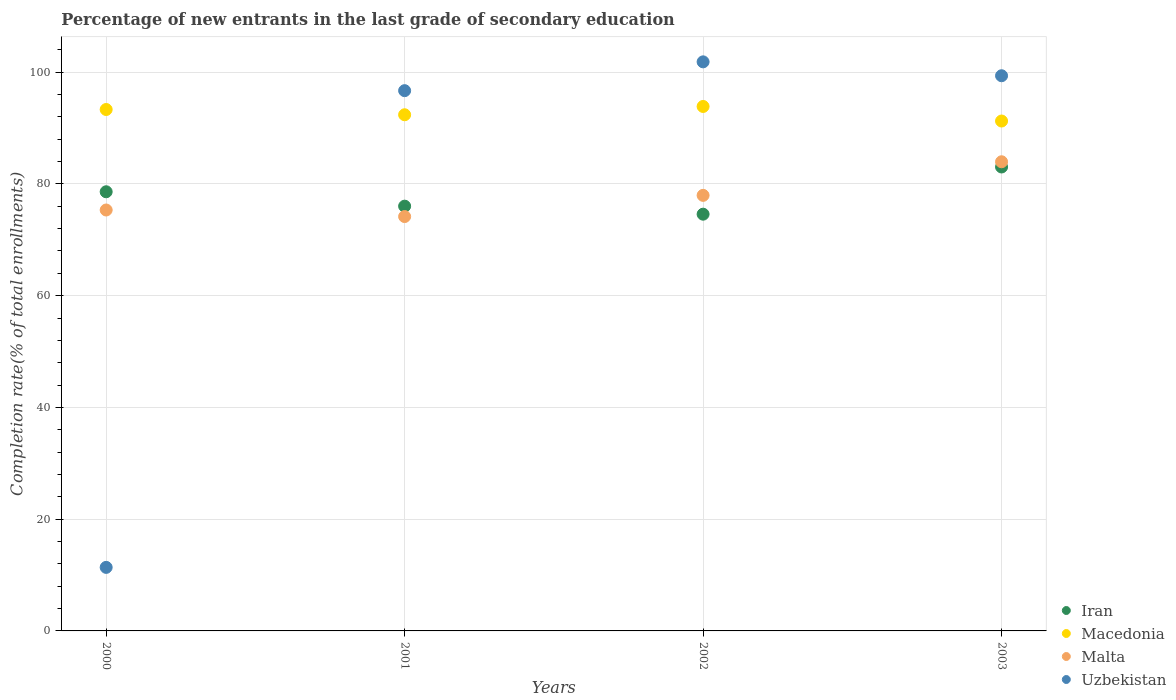How many different coloured dotlines are there?
Provide a succinct answer. 4. What is the percentage of new entrants in Iran in 2000?
Ensure brevity in your answer.  78.59. Across all years, what is the maximum percentage of new entrants in Iran?
Offer a very short reply. 83.03. Across all years, what is the minimum percentage of new entrants in Uzbekistan?
Give a very brief answer. 11.37. In which year was the percentage of new entrants in Malta maximum?
Provide a succinct answer. 2003. What is the total percentage of new entrants in Malta in the graph?
Keep it short and to the point. 311.4. What is the difference between the percentage of new entrants in Malta in 2000 and that in 2001?
Make the answer very short. 1.17. What is the difference between the percentage of new entrants in Uzbekistan in 2000 and the percentage of new entrants in Macedonia in 2001?
Your answer should be very brief. -81. What is the average percentage of new entrants in Macedonia per year?
Provide a short and direct response. 92.7. In the year 2003, what is the difference between the percentage of new entrants in Malta and percentage of new entrants in Macedonia?
Offer a very short reply. -7.29. In how many years, is the percentage of new entrants in Uzbekistan greater than 8 %?
Offer a terse response. 4. What is the ratio of the percentage of new entrants in Macedonia in 2000 to that in 2001?
Give a very brief answer. 1.01. Is the percentage of new entrants in Uzbekistan in 2001 less than that in 2003?
Offer a very short reply. Yes. What is the difference between the highest and the second highest percentage of new entrants in Iran?
Your answer should be compact. 4.44. What is the difference between the highest and the lowest percentage of new entrants in Macedonia?
Offer a very short reply. 2.61. In how many years, is the percentage of new entrants in Uzbekistan greater than the average percentage of new entrants in Uzbekistan taken over all years?
Your answer should be compact. 3. Is the sum of the percentage of new entrants in Iran in 2001 and 2003 greater than the maximum percentage of new entrants in Malta across all years?
Your answer should be compact. Yes. Is it the case that in every year, the sum of the percentage of new entrants in Uzbekistan and percentage of new entrants in Macedonia  is greater than the sum of percentage of new entrants in Iran and percentage of new entrants in Malta?
Your response must be concise. No. Does the percentage of new entrants in Uzbekistan monotonically increase over the years?
Your answer should be very brief. No. Is the percentage of new entrants in Uzbekistan strictly greater than the percentage of new entrants in Iran over the years?
Your response must be concise. No. How many dotlines are there?
Your answer should be very brief. 4. What is the difference between two consecutive major ticks on the Y-axis?
Your response must be concise. 20. Does the graph contain grids?
Make the answer very short. Yes. Where does the legend appear in the graph?
Give a very brief answer. Bottom right. How many legend labels are there?
Offer a very short reply. 4. How are the legend labels stacked?
Ensure brevity in your answer.  Vertical. What is the title of the graph?
Ensure brevity in your answer.  Percentage of new entrants in the last grade of secondary education. What is the label or title of the X-axis?
Offer a terse response. Years. What is the label or title of the Y-axis?
Offer a terse response. Completion rate(% of total enrollments). What is the Completion rate(% of total enrollments) of Iran in 2000?
Provide a short and direct response. 78.59. What is the Completion rate(% of total enrollments) in Macedonia in 2000?
Your answer should be very brief. 93.31. What is the Completion rate(% of total enrollments) in Malta in 2000?
Provide a short and direct response. 75.33. What is the Completion rate(% of total enrollments) in Uzbekistan in 2000?
Provide a short and direct response. 11.37. What is the Completion rate(% of total enrollments) in Iran in 2001?
Your answer should be compact. 76.02. What is the Completion rate(% of total enrollments) in Macedonia in 2001?
Your response must be concise. 92.37. What is the Completion rate(% of total enrollments) of Malta in 2001?
Make the answer very short. 74.16. What is the Completion rate(% of total enrollments) of Uzbekistan in 2001?
Make the answer very short. 96.69. What is the Completion rate(% of total enrollments) of Iran in 2002?
Keep it short and to the point. 74.58. What is the Completion rate(% of total enrollments) in Macedonia in 2002?
Offer a very short reply. 93.86. What is the Completion rate(% of total enrollments) in Malta in 2002?
Make the answer very short. 77.95. What is the Completion rate(% of total enrollments) in Uzbekistan in 2002?
Offer a very short reply. 101.84. What is the Completion rate(% of total enrollments) of Iran in 2003?
Your answer should be compact. 83.03. What is the Completion rate(% of total enrollments) in Macedonia in 2003?
Keep it short and to the point. 91.25. What is the Completion rate(% of total enrollments) of Malta in 2003?
Give a very brief answer. 83.96. What is the Completion rate(% of total enrollments) in Uzbekistan in 2003?
Provide a short and direct response. 99.36. Across all years, what is the maximum Completion rate(% of total enrollments) of Iran?
Make the answer very short. 83.03. Across all years, what is the maximum Completion rate(% of total enrollments) of Macedonia?
Your answer should be compact. 93.86. Across all years, what is the maximum Completion rate(% of total enrollments) of Malta?
Provide a short and direct response. 83.96. Across all years, what is the maximum Completion rate(% of total enrollments) in Uzbekistan?
Your response must be concise. 101.84. Across all years, what is the minimum Completion rate(% of total enrollments) in Iran?
Make the answer very short. 74.58. Across all years, what is the minimum Completion rate(% of total enrollments) of Macedonia?
Your answer should be compact. 91.25. Across all years, what is the minimum Completion rate(% of total enrollments) in Malta?
Provide a succinct answer. 74.16. Across all years, what is the minimum Completion rate(% of total enrollments) of Uzbekistan?
Your response must be concise. 11.37. What is the total Completion rate(% of total enrollments) of Iran in the graph?
Your response must be concise. 312.22. What is the total Completion rate(% of total enrollments) in Macedonia in the graph?
Give a very brief answer. 370.8. What is the total Completion rate(% of total enrollments) in Malta in the graph?
Give a very brief answer. 311.4. What is the total Completion rate(% of total enrollments) in Uzbekistan in the graph?
Your answer should be compact. 309.26. What is the difference between the Completion rate(% of total enrollments) in Iran in 2000 and that in 2001?
Make the answer very short. 2.58. What is the difference between the Completion rate(% of total enrollments) in Macedonia in 2000 and that in 2001?
Give a very brief answer. 0.94. What is the difference between the Completion rate(% of total enrollments) of Malta in 2000 and that in 2001?
Your response must be concise. 1.17. What is the difference between the Completion rate(% of total enrollments) in Uzbekistan in 2000 and that in 2001?
Provide a succinct answer. -85.31. What is the difference between the Completion rate(% of total enrollments) of Iran in 2000 and that in 2002?
Give a very brief answer. 4.01. What is the difference between the Completion rate(% of total enrollments) in Macedonia in 2000 and that in 2002?
Your response must be concise. -0.54. What is the difference between the Completion rate(% of total enrollments) of Malta in 2000 and that in 2002?
Your answer should be very brief. -2.62. What is the difference between the Completion rate(% of total enrollments) of Uzbekistan in 2000 and that in 2002?
Keep it short and to the point. -90.47. What is the difference between the Completion rate(% of total enrollments) in Iran in 2000 and that in 2003?
Make the answer very short. -4.44. What is the difference between the Completion rate(% of total enrollments) in Macedonia in 2000 and that in 2003?
Your response must be concise. 2.06. What is the difference between the Completion rate(% of total enrollments) of Malta in 2000 and that in 2003?
Provide a short and direct response. -8.63. What is the difference between the Completion rate(% of total enrollments) in Uzbekistan in 2000 and that in 2003?
Make the answer very short. -87.98. What is the difference between the Completion rate(% of total enrollments) of Iran in 2001 and that in 2002?
Give a very brief answer. 1.43. What is the difference between the Completion rate(% of total enrollments) in Macedonia in 2001 and that in 2002?
Offer a very short reply. -1.49. What is the difference between the Completion rate(% of total enrollments) in Malta in 2001 and that in 2002?
Give a very brief answer. -3.79. What is the difference between the Completion rate(% of total enrollments) in Uzbekistan in 2001 and that in 2002?
Make the answer very short. -5.16. What is the difference between the Completion rate(% of total enrollments) of Iran in 2001 and that in 2003?
Your answer should be very brief. -7.01. What is the difference between the Completion rate(% of total enrollments) in Macedonia in 2001 and that in 2003?
Your response must be concise. 1.12. What is the difference between the Completion rate(% of total enrollments) in Malta in 2001 and that in 2003?
Offer a terse response. -9.81. What is the difference between the Completion rate(% of total enrollments) in Uzbekistan in 2001 and that in 2003?
Give a very brief answer. -2.67. What is the difference between the Completion rate(% of total enrollments) of Iran in 2002 and that in 2003?
Your response must be concise. -8.45. What is the difference between the Completion rate(% of total enrollments) in Macedonia in 2002 and that in 2003?
Your answer should be very brief. 2.61. What is the difference between the Completion rate(% of total enrollments) of Malta in 2002 and that in 2003?
Your answer should be compact. -6.01. What is the difference between the Completion rate(% of total enrollments) in Uzbekistan in 2002 and that in 2003?
Offer a terse response. 2.49. What is the difference between the Completion rate(% of total enrollments) of Iran in 2000 and the Completion rate(% of total enrollments) of Macedonia in 2001?
Provide a succinct answer. -13.78. What is the difference between the Completion rate(% of total enrollments) of Iran in 2000 and the Completion rate(% of total enrollments) of Malta in 2001?
Make the answer very short. 4.44. What is the difference between the Completion rate(% of total enrollments) in Iran in 2000 and the Completion rate(% of total enrollments) in Uzbekistan in 2001?
Make the answer very short. -18.09. What is the difference between the Completion rate(% of total enrollments) in Macedonia in 2000 and the Completion rate(% of total enrollments) in Malta in 2001?
Offer a terse response. 19.16. What is the difference between the Completion rate(% of total enrollments) of Macedonia in 2000 and the Completion rate(% of total enrollments) of Uzbekistan in 2001?
Give a very brief answer. -3.37. What is the difference between the Completion rate(% of total enrollments) of Malta in 2000 and the Completion rate(% of total enrollments) of Uzbekistan in 2001?
Make the answer very short. -21.36. What is the difference between the Completion rate(% of total enrollments) in Iran in 2000 and the Completion rate(% of total enrollments) in Macedonia in 2002?
Provide a short and direct response. -15.27. What is the difference between the Completion rate(% of total enrollments) in Iran in 2000 and the Completion rate(% of total enrollments) in Malta in 2002?
Offer a terse response. 0.64. What is the difference between the Completion rate(% of total enrollments) of Iran in 2000 and the Completion rate(% of total enrollments) of Uzbekistan in 2002?
Provide a succinct answer. -23.25. What is the difference between the Completion rate(% of total enrollments) of Macedonia in 2000 and the Completion rate(% of total enrollments) of Malta in 2002?
Ensure brevity in your answer.  15.37. What is the difference between the Completion rate(% of total enrollments) of Macedonia in 2000 and the Completion rate(% of total enrollments) of Uzbekistan in 2002?
Ensure brevity in your answer.  -8.53. What is the difference between the Completion rate(% of total enrollments) of Malta in 2000 and the Completion rate(% of total enrollments) of Uzbekistan in 2002?
Keep it short and to the point. -26.51. What is the difference between the Completion rate(% of total enrollments) in Iran in 2000 and the Completion rate(% of total enrollments) in Macedonia in 2003?
Make the answer very short. -12.66. What is the difference between the Completion rate(% of total enrollments) of Iran in 2000 and the Completion rate(% of total enrollments) of Malta in 2003?
Your response must be concise. -5.37. What is the difference between the Completion rate(% of total enrollments) in Iran in 2000 and the Completion rate(% of total enrollments) in Uzbekistan in 2003?
Your answer should be very brief. -20.76. What is the difference between the Completion rate(% of total enrollments) of Macedonia in 2000 and the Completion rate(% of total enrollments) of Malta in 2003?
Ensure brevity in your answer.  9.35. What is the difference between the Completion rate(% of total enrollments) in Macedonia in 2000 and the Completion rate(% of total enrollments) in Uzbekistan in 2003?
Offer a terse response. -6.04. What is the difference between the Completion rate(% of total enrollments) of Malta in 2000 and the Completion rate(% of total enrollments) of Uzbekistan in 2003?
Offer a very short reply. -24.03. What is the difference between the Completion rate(% of total enrollments) of Iran in 2001 and the Completion rate(% of total enrollments) of Macedonia in 2002?
Your answer should be very brief. -17.84. What is the difference between the Completion rate(% of total enrollments) of Iran in 2001 and the Completion rate(% of total enrollments) of Malta in 2002?
Provide a succinct answer. -1.93. What is the difference between the Completion rate(% of total enrollments) in Iran in 2001 and the Completion rate(% of total enrollments) in Uzbekistan in 2002?
Offer a very short reply. -25.83. What is the difference between the Completion rate(% of total enrollments) in Macedonia in 2001 and the Completion rate(% of total enrollments) in Malta in 2002?
Offer a terse response. 14.43. What is the difference between the Completion rate(% of total enrollments) of Macedonia in 2001 and the Completion rate(% of total enrollments) of Uzbekistan in 2002?
Provide a short and direct response. -9.47. What is the difference between the Completion rate(% of total enrollments) of Malta in 2001 and the Completion rate(% of total enrollments) of Uzbekistan in 2002?
Offer a very short reply. -27.69. What is the difference between the Completion rate(% of total enrollments) of Iran in 2001 and the Completion rate(% of total enrollments) of Macedonia in 2003?
Your answer should be very brief. -15.24. What is the difference between the Completion rate(% of total enrollments) in Iran in 2001 and the Completion rate(% of total enrollments) in Malta in 2003?
Your answer should be very brief. -7.95. What is the difference between the Completion rate(% of total enrollments) in Iran in 2001 and the Completion rate(% of total enrollments) in Uzbekistan in 2003?
Make the answer very short. -23.34. What is the difference between the Completion rate(% of total enrollments) in Macedonia in 2001 and the Completion rate(% of total enrollments) in Malta in 2003?
Keep it short and to the point. 8.41. What is the difference between the Completion rate(% of total enrollments) of Macedonia in 2001 and the Completion rate(% of total enrollments) of Uzbekistan in 2003?
Your answer should be compact. -6.98. What is the difference between the Completion rate(% of total enrollments) of Malta in 2001 and the Completion rate(% of total enrollments) of Uzbekistan in 2003?
Your response must be concise. -25.2. What is the difference between the Completion rate(% of total enrollments) of Iran in 2002 and the Completion rate(% of total enrollments) of Macedonia in 2003?
Your answer should be compact. -16.67. What is the difference between the Completion rate(% of total enrollments) of Iran in 2002 and the Completion rate(% of total enrollments) of Malta in 2003?
Provide a short and direct response. -9.38. What is the difference between the Completion rate(% of total enrollments) in Iran in 2002 and the Completion rate(% of total enrollments) in Uzbekistan in 2003?
Your answer should be very brief. -24.78. What is the difference between the Completion rate(% of total enrollments) of Macedonia in 2002 and the Completion rate(% of total enrollments) of Malta in 2003?
Give a very brief answer. 9.9. What is the difference between the Completion rate(% of total enrollments) of Macedonia in 2002 and the Completion rate(% of total enrollments) of Uzbekistan in 2003?
Provide a succinct answer. -5.5. What is the difference between the Completion rate(% of total enrollments) of Malta in 2002 and the Completion rate(% of total enrollments) of Uzbekistan in 2003?
Make the answer very short. -21.41. What is the average Completion rate(% of total enrollments) in Iran per year?
Your answer should be very brief. 78.05. What is the average Completion rate(% of total enrollments) of Macedonia per year?
Your answer should be compact. 92.7. What is the average Completion rate(% of total enrollments) in Malta per year?
Your response must be concise. 77.85. What is the average Completion rate(% of total enrollments) in Uzbekistan per year?
Your answer should be very brief. 77.31. In the year 2000, what is the difference between the Completion rate(% of total enrollments) in Iran and Completion rate(% of total enrollments) in Macedonia?
Offer a very short reply. -14.72. In the year 2000, what is the difference between the Completion rate(% of total enrollments) in Iran and Completion rate(% of total enrollments) in Malta?
Provide a short and direct response. 3.26. In the year 2000, what is the difference between the Completion rate(% of total enrollments) of Iran and Completion rate(% of total enrollments) of Uzbekistan?
Offer a very short reply. 67.22. In the year 2000, what is the difference between the Completion rate(% of total enrollments) of Macedonia and Completion rate(% of total enrollments) of Malta?
Make the answer very short. 17.99. In the year 2000, what is the difference between the Completion rate(% of total enrollments) of Macedonia and Completion rate(% of total enrollments) of Uzbekistan?
Keep it short and to the point. 81.94. In the year 2000, what is the difference between the Completion rate(% of total enrollments) in Malta and Completion rate(% of total enrollments) in Uzbekistan?
Your answer should be very brief. 63.96. In the year 2001, what is the difference between the Completion rate(% of total enrollments) in Iran and Completion rate(% of total enrollments) in Macedonia?
Your answer should be very brief. -16.36. In the year 2001, what is the difference between the Completion rate(% of total enrollments) in Iran and Completion rate(% of total enrollments) in Malta?
Make the answer very short. 1.86. In the year 2001, what is the difference between the Completion rate(% of total enrollments) in Iran and Completion rate(% of total enrollments) in Uzbekistan?
Keep it short and to the point. -20.67. In the year 2001, what is the difference between the Completion rate(% of total enrollments) in Macedonia and Completion rate(% of total enrollments) in Malta?
Offer a very short reply. 18.22. In the year 2001, what is the difference between the Completion rate(% of total enrollments) of Macedonia and Completion rate(% of total enrollments) of Uzbekistan?
Your answer should be very brief. -4.31. In the year 2001, what is the difference between the Completion rate(% of total enrollments) of Malta and Completion rate(% of total enrollments) of Uzbekistan?
Make the answer very short. -22.53. In the year 2002, what is the difference between the Completion rate(% of total enrollments) of Iran and Completion rate(% of total enrollments) of Macedonia?
Provide a short and direct response. -19.28. In the year 2002, what is the difference between the Completion rate(% of total enrollments) of Iran and Completion rate(% of total enrollments) of Malta?
Offer a very short reply. -3.37. In the year 2002, what is the difference between the Completion rate(% of total enrollments) of Iran and Completion rate(% of total enrollments) of Uzbekistan?
Provide a short and direct response. -27.26. In the year 2002, what is the difference between the Completion rate(% of total enrollments) of Macedonia and Completion rate(% of total enrollments) of Malta?
Make the answer very short. 15.91. In the year 2002, what is the difference between the Completion rate(% of total enrollments) of Macedonia and Completion rate(% of total enrollments) of Uzbekistan?
Offer a terse response. -7.98. In the year 2002, what is the difference between the Completion rate(% of total enrollments) in Malta and Completion rate(% of total enrollments) in Uzbekistan?
Provide a succinct answer. -23.89. In the year 2003, what is the difference between the Completion rate(% of total enrollments) of Iran and Completion rate(% of total enrollments) of Macedonia?
Keep it short and to the point. -8.22. In the year 2003, what is the difference between the Completion rate(% of total enrollments) of Iran and Completion rate(% of total enrollments) of Malta?
Keep it short and to the point. -0.93. In the year 2003, what is the difference between the Completion rate(% of total enrollments) in Iran and Completion rate(% of total enrollments) in Uzbekistan?
Ensure brevity in your answer.  -16.33. In the year 2003, what is the difference between the Completion rate(% of total enrollments) in Macedonia and Completion rate(% of total enrollments) in Malta?
Give a very brief answer. 7.29. In the year 2003, what is the difference between the Completion rate(% of total enrollments) in Macedonia and Completion rate(% of total enrollments) in Uzbekistan?
Provide a short and direct response. -8.1. In the year 2003, what is the difference between the Completion rate(% of total enrollments) in Malta and Completion rate(% of total enrollments) in Uzbekistan?
Ensure brevity in your answer.  -15.39. What is the ratio of the Completion rate(% of total enrollments) in Iran in 2000 to that in 2001?
Give a very brief answer. 1.03. What is the ratio of the Completion rate(% of total enrollments) of Macedonia in 2000 to that in 2001?
Provide a short and direct response. 1.01. What is the ratio of the Completion rate(% of total enrollments) of Malta in 2000 to that in 2001?
Provide a succinct answer. 1.02. What is the ratio of the Completion rate(% of total enrollments) in Uzbekistan in 2000 to that in 2001?
Your answer should be compact. 0.12. What is the ratio of the Completion rate(% of total enrollments) of Iran in 2000 to that in 2002?
Offer a terse response. 1.05. What is the ratio of the Completion rate(% of total enrollments) in Malta in 2000 to that in 2002?
Ensure brevity in your answer.  0.97. What is the ratio of the Completion rate(% of total enrollments) of Uzbekistan in 2000 to that in 2002?
Keep it short and to the point. 0.11. What is the ratio of the Completion rate(% of total enrollments) of Iran in 2000 to that in 2003?
Offer a terse response. 0.95. What is the ratio of the Completion rate(% of total enrollments) of Macedonia in 2000 to that in 2003?
Make the answer very short. 1.02. What is the ratio of the Completion rate(% of total enrollments) of Malta in 2000 to that in 2003?
Make the answer very short. 0.9. What is the ratio of the Completion rate(% of total enrollments) in Uzbekistan in 2000 to that in 2003?
Your response must be concise. 0.11. What is the ratio of the Completion rate(% of total enrollments) of Iran in 2001 to that in 2002?
Your answer should be very brief. 1.02. What is the ratio of the Completion rate(% of total enrollments) in Macedonia in 2001 to that in 2002?
Provide a succinct answer. 0.98. What is the ratio of the Completion rate(% of total enrollments) in Malta in 2001 to that in 2002?
Your answer should be compact. 0.95. What is the ratio of the Completion rate(% of total enrollments) of Uzbekistan in 2001 to that in 2002?
Offer a very short reply. 0.95. What is the ratio of the Completion rate(% of total enrollments) of Iran in 2001 to that in 2003?
Your answer should be compact. 0.92. What is the ratio of the Completion rate(% of total enrollments) of Macedonia in 2001 to that in 2003?
Your response must be concise. 1.01. What is the ratio of the Completion rate(% of total enrollments) in Malta in 2001 to that in 2003?
Your response must be concise. 0.88. What is the ratio of the Completion rate(% of total enrollments) in Uzbekistan in 2001 to that in 2003?
Ensure brevity in your answer.  0.97. What is the ratio of the Completion rate(% of total enrollments) in Iran in 2002 to that in 2003?
Your response must be concise. 0.9. What is the ratio of the Completion rate(% of total enrollments) in Macedonia in 2002 to that in 2003?
Give a very brief answer. 1.03. What is the ratio of the Completion rate(% of total enrollments) of Malta in 2002 to that in 2003?
Offer a very short reply. 0.93. What is the difference between the highest and the second highest Completion rate(% of total enrollments) of Iran?
Provide a short and direct response. 4.44. What is the difference between the highest and the second highest Completion rate(% of total enrollments) in Macedonia?
Give a very brief answer. 0.54. What is the difference between the highest and the second highest Completion rate(% of total enrollments) of Malta?
Your answer should be very brief. 6.01. What is the difference between the highest and the second highest Completion rate(% of total enrollments) in Uzbekistan?
Your answer should be very brief. 2.49. What is the difference between the highest and the lowest Completion rate(% of total enrollments) in Iran?
Provide a succinct answer. 8.45. What is the difference between the highest and the lowest Completion rate(% of total enrollments) of Macedonia?
Provide a succinct answer. 2.61. What is the difference between the highest and the lowest Completion rate(% of total enrollments) of Malta?
Make the answer very short. 9.81. What is the difference between the highest and the lowest Completion rate(% of total enrollments) in Uzbekistan?
Make the answer very short. 90.47. 